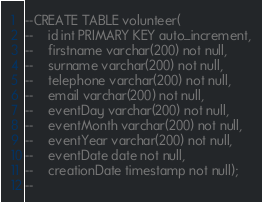<code> <loc_0><loc_0><loc_500><loc_500><_SQL_>--CREATE TABLE volunteer(
--    id int PRIMARY KEY auto_increment,
--    firstname varchar(200) not null,
--    surname varchar(200) not null,
--    telephone varchar(200) not null,
--    email varchar(200) not null,
--    eventDay varchar(200) not null,
--    eventMonth varchar(200) not null,
--    eventYear varchar(200) not null,
--    eventDate date not null,
--    creationDate timestamp not null);
--
</code> 